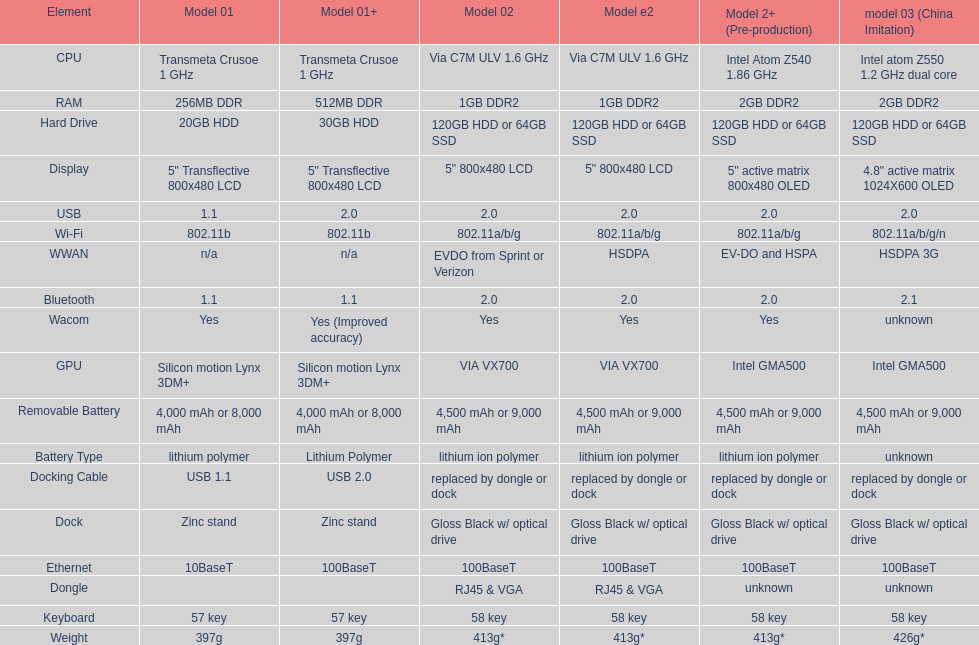How much more weight does the model 3 have over model 1? 29g. 